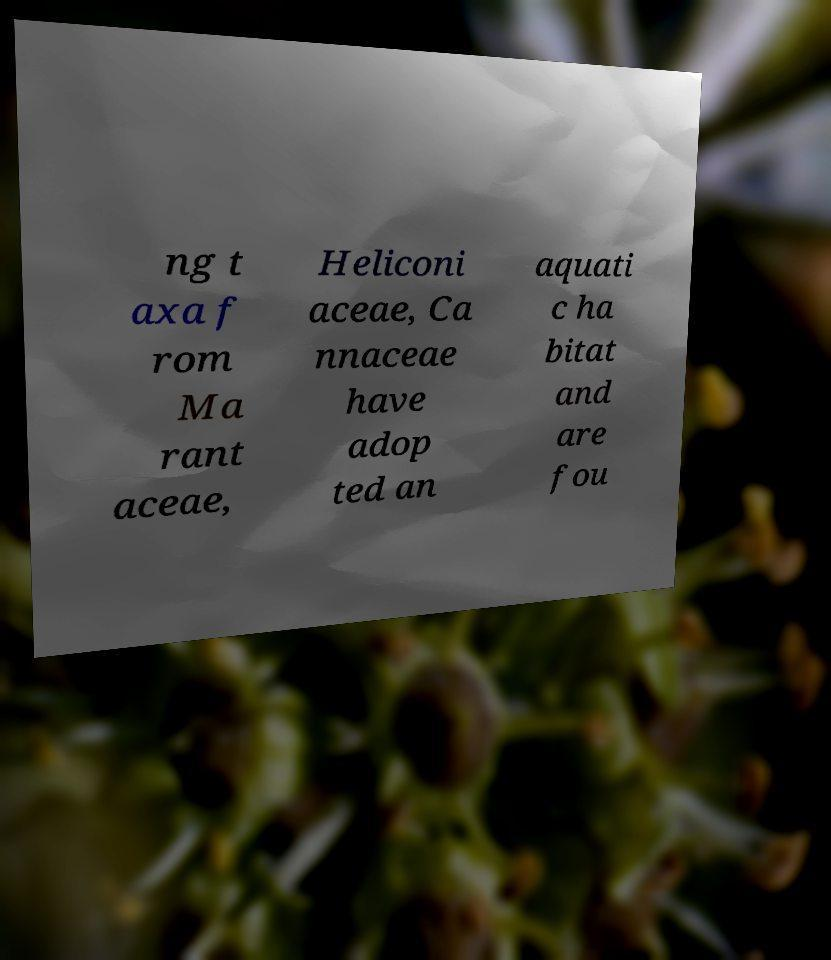I need the written content from this picture converted into text. Can you do that? ng t axa f rom Ma rant aceae, Heliconi aceae, Ca nnaceae have adop ted an aquati c ha bitat and are fou 